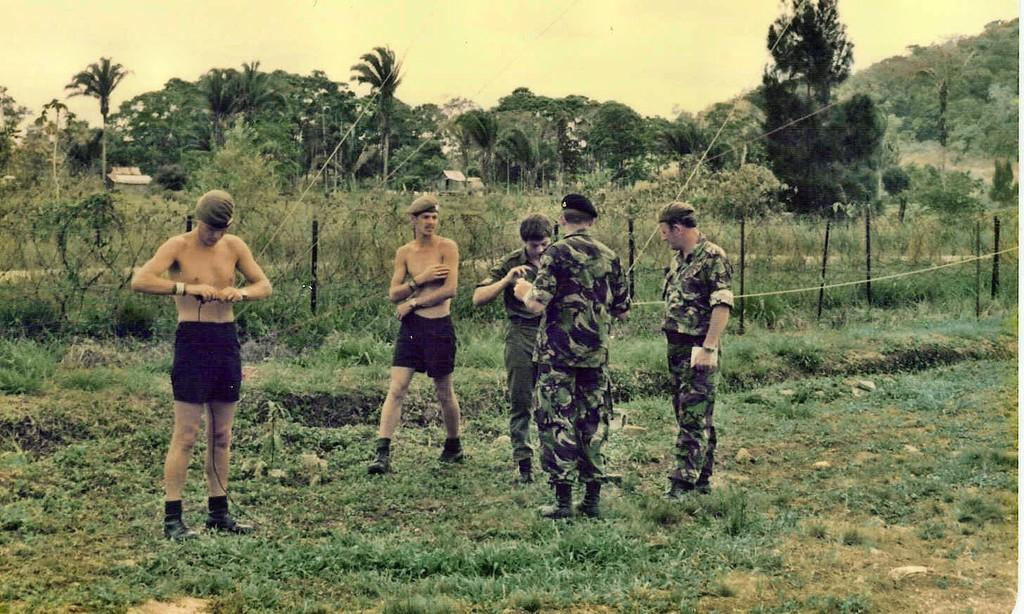How many people are in the image? There are people in the image, but the exact number is not specified. What is the surface the people are standing on? The people are standing on the grass. What type of clothing accessory can be seen on some people? Some people are wearing caps. What can be seen in the background of the image? In the background of the image, there is a fence, trees, and houses. What type of meat is being grilled in the image? There is no indication of any meat or grilling activity in the image. 